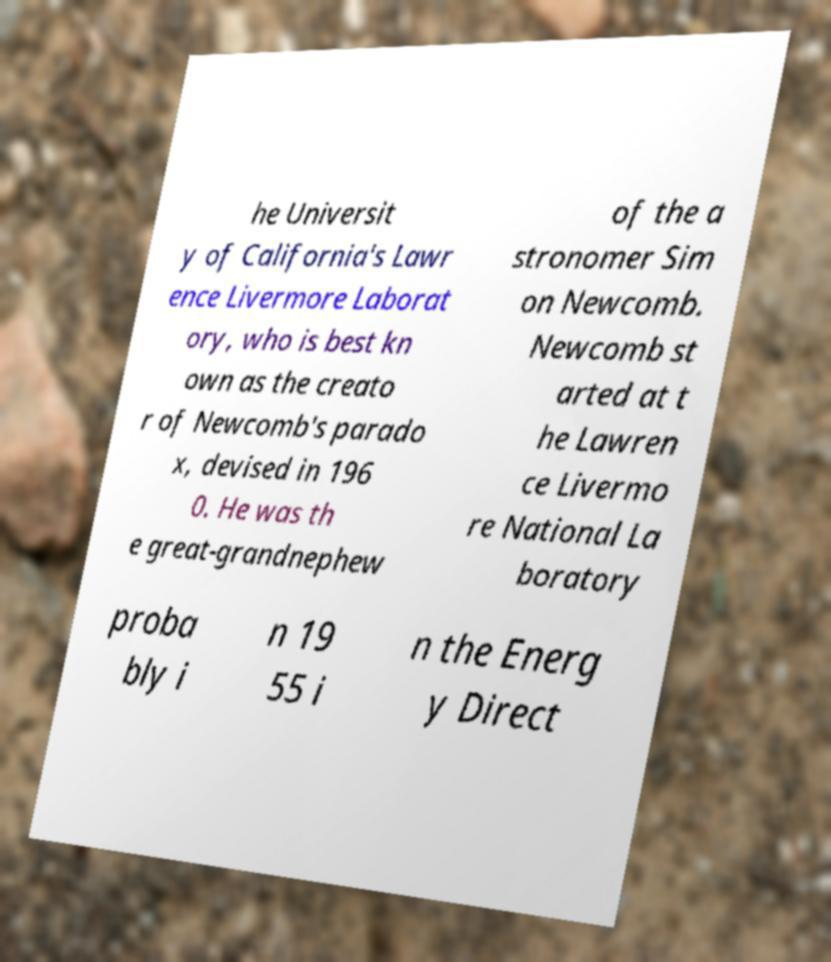Can you read and provide the text displayed in the image?This photo seems to have some interesting text. Can you extract and type it out for me? he Universit y of California's Lawr ence Livermore Laborat ory, who is best kn own as the creato r of Newcomb's parado x, devised in 196 0. He was th e great-grandnephew of the a stronomer Sim on Newcomb. Newcomb st arted at t he Lawren ce Livermo re National La boratory proba bly i n 19 55 i n the Energ y Direct 